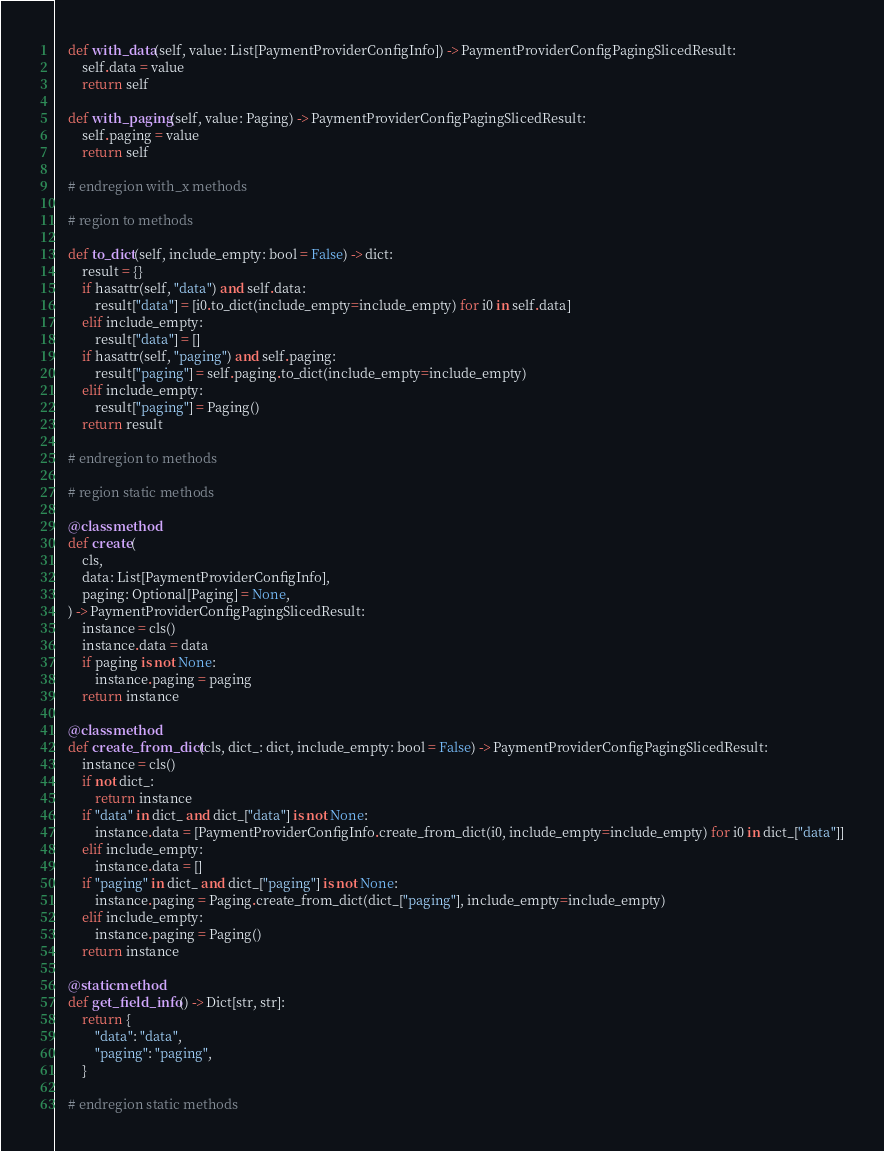Convert code to text. <code><loc_0><loc_0><loc_500><loc_500><_Python_>
    def with_data(self, value: List[PaymentProviderConfigInfo]) -> PaymentProviderConfigPagingSlicedResult:
        self.data = value
        return self

    def with_paging(self, value: Paging) -> PaymentProviderConfigPagingSlicedResult:
        self.paging = value
        return self

    # endregion with_x methods

    # region to methods

    def to_dict(self, include_empty: bool = False) -> dict:
        result = {}
        if hasattr(self, "data") and self.data:
            result["data"] = [i0.to_dict(include_empty=include_empty) for i0 in self.data]
        elif include_empty:
            result["data"] = []
        if hasattr(self, "paging") and self.paging:
            result["paging"] = self.paging.to_dict(include_empty=include_empty)
        elif include_empty:
            result["paging"] = Paging()
        return result

    # endregion to methods

    # region static methods

    @classmethod
    def create(
        cls,
        data: List[PaymentProviderConfigInfo],
        paging: Optional[Paging] = None,
    ) -> PaymentProviderConfigPagingSlicedResult:
        instance = cls()
        instance.data = data
        if paging is not None:
            instance.paging = paging
        return instance

    @classmethod
    def create_from_dict(cls, dict_: dict, include_empty: bool = False) -> PaymentProviderConfigPagingSlicedResult:
        instance = cls()
        if not dict_:
            return instance
        if "data" in dict_ and dict_["data"] is not None:
            instance.data = [PaymentProviderConfigInfo.create_from_dict(i0, include_empty=include_empty) for i0 in dict_["data"]]
        elif include_empty:
            instance.data = []
        if "paging" in dict_ and dict_["paging"] is not None:
            instance.paging = Paging.create_from_dict(dict_["paging"], include_empty=include_empty)
        elif include_empty:
            instance.paging = Paging()
        return instance

    @staticmethod
    def get_field_info() -> Dict[str, str]:
        return {
            "data": "data",
            "paging": "paging",
        }

    # endregion static methods
</code> 